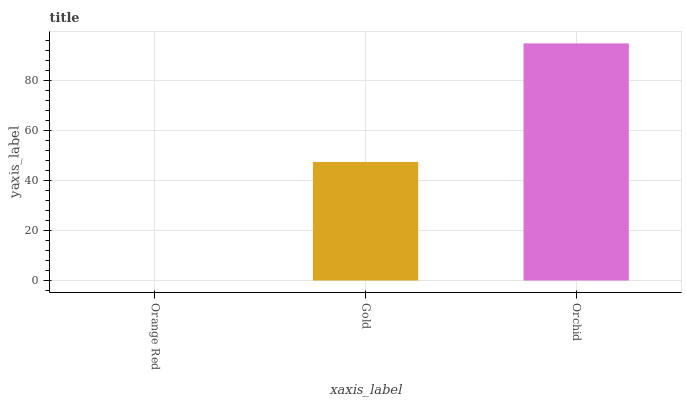Is Gold the minimum?
Answer yes or no. No. Is Gold the maximum?
Answer yes or no. No. Is Gold greater than Orange Red?
Answer yes or no. Yes. Is Orange Red less than Gold?
Answer yes or no. Yes. Is Orange Red greater than Gold?
Answer yes or no. No. Is Gold less than Orange Red?
Answer yes or no. No. Is Gold the high median?
Answer yes or no. Yes. Is Gold the low median?
Answer yes or no. Yes. Is Orange Red the high median?
Answer yes or no. No. Is Orange Red the low median?
Answer yes or no. No. 